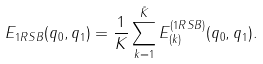Convert formula to latex. <formula><loc_0><loc_0><loc_500><loc_500>E _ { 1 R S B } ( q _ { 0 } , q _ { 1 } ) = \frac { 1 } { K } \sum _ { k = 1 } ^ { \tilde { K } } E _ { ( k ) } ^ { ( 1 R S B ) } ( q _ { 0 } , q _ { 1 } ) .</formula> 